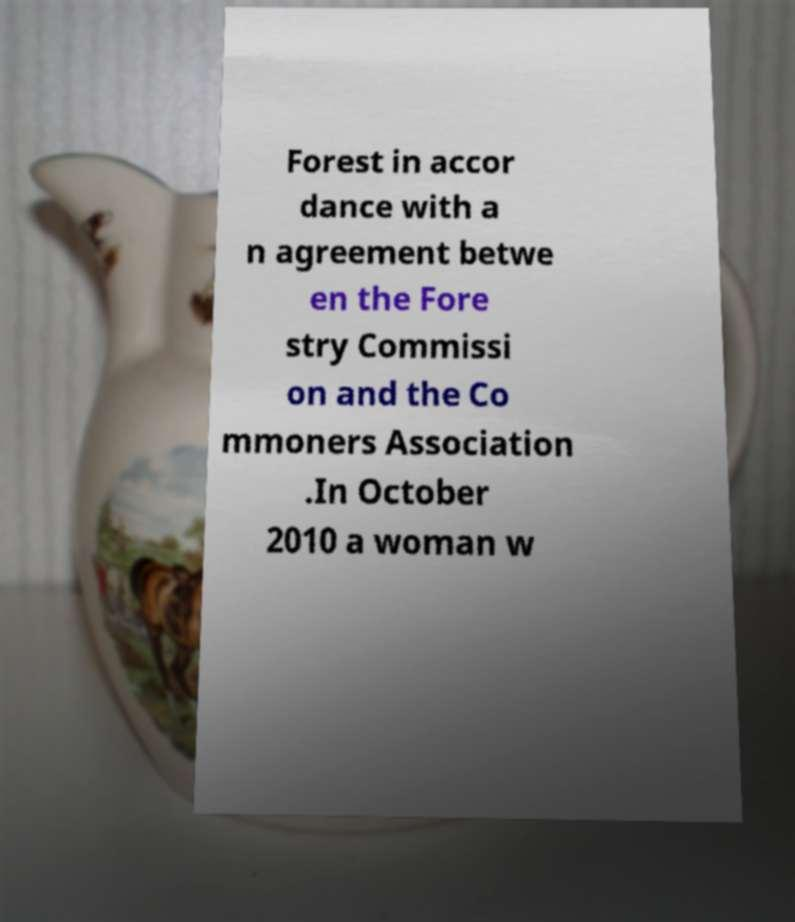Please read and relay the text visible in this image. What does it say? Forest in accor dance with a n agreement betwe en the Fore stry Commissi on and the Co mmoners Association .In October 2010 a woman w 